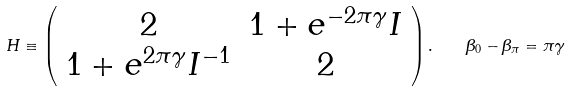<formula> <loc_0><loc_0><loc_500><loc_500>H \equiv \left ( \begin{array} { c c } 2 & 1 + e ^ { - 2 \pi \gamma } I \\ 1 + e ^ { 2 \pi \gamma } I ^ { - 1 } & 2 \\ \end{array} \right ) . \quad \beta _ { 0 } - \beta _ { \pi } = \pi \gamma</formula> 